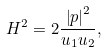<formula> <loc_0><loc_0><loc_500><loc_500>H ^ { 2 } = 2 \frac { \left | p \right | ^ { 2 } } { u _ { 1 } u _ { 2 } } ,</formula> 